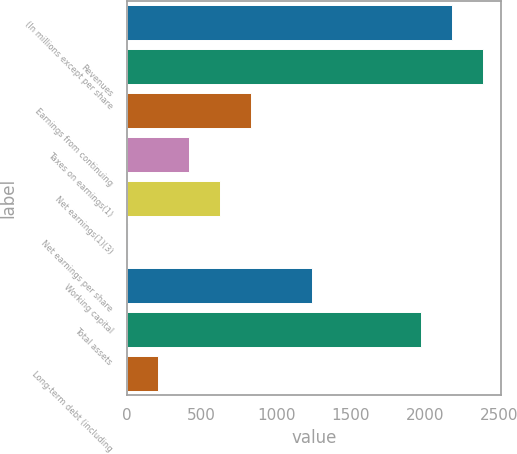<chart> <loc_0><loc_0><loc_500><loc_500><bar_chart><fcel>(In millions except per share<fcel>Revenues<fcel>Earnings from continuing<fcel>Taxes on earnings(1)<fcel>Net earnings(1)(3)<fcel>Net earnings per share<fcel>Working capital<fcel>Total assets<fcel>Long-term debt (including<nl><fcel>2182.25<fcel>2389<fcel>829.19<fcel>415.69<fcel>622.44<fcel>2.19<fcel>1242.69<fcel>1975.5<fcel>208.94<nl></chart> 